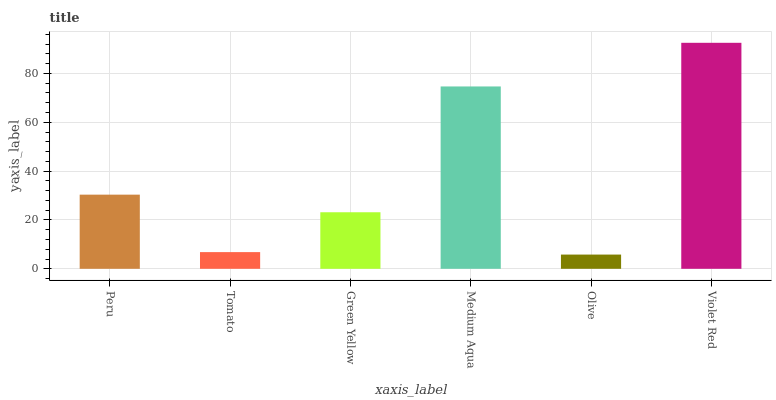Is Olive the minimum?
Answer yes or no. Yes. Is Violet Red the maximum?
Answer yes or no. Yes. Is Tomato the minimum?
Answer yes or no. No. Is Tomato the maximum?
Answer yes or no. No. Is Peru greater than Tomato?
Answer yes or no. Yes. Is Tomato less than Peru?
Answer yes or no. Yes. Is Tomato greater than Peru?
Answer yes or no. No. Is Peru less than Tomato?
Answer yes or no. No. Is Peru the high median?
Answer yes or no. Yes. Is Green Yellow the low median?
Answer yes or no. Yes. Is Tomato the high median?
Answer yes or no. No. Is Olive the low median?
Answer yes or no. No. 